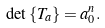Convert formula to latex. <formula><loc_0><loc_0><loc_500><loc_500>\det \left \{ T _ { a } \right \} = a _ { 0 } ^ { n } .</formula> 